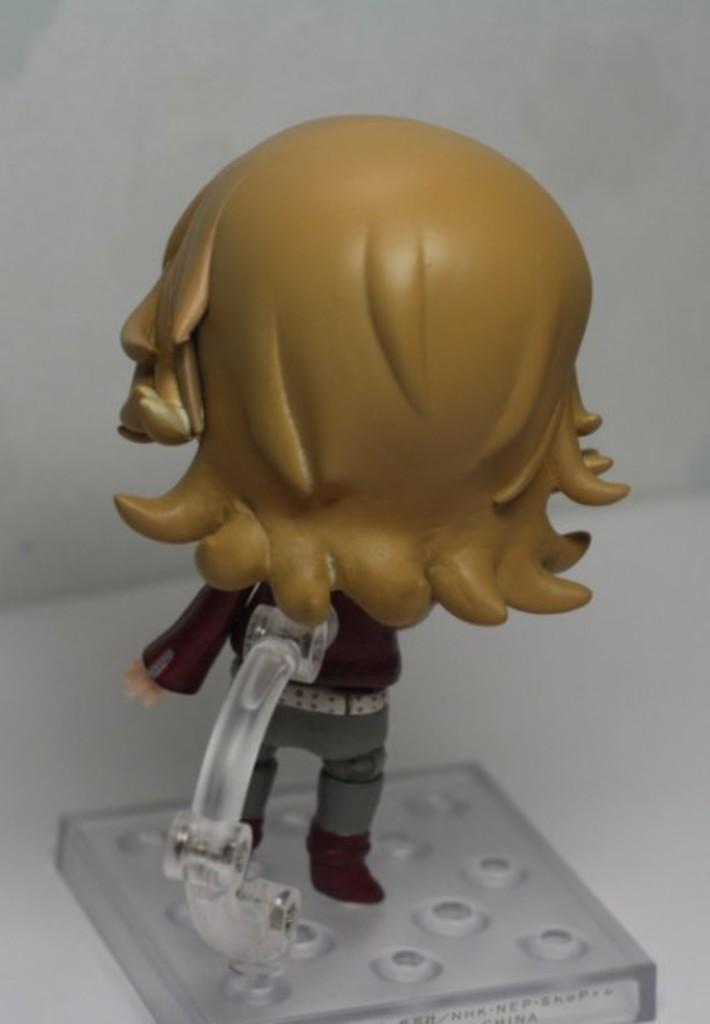Can you describe this image briefly? It is a toy on a glass. 